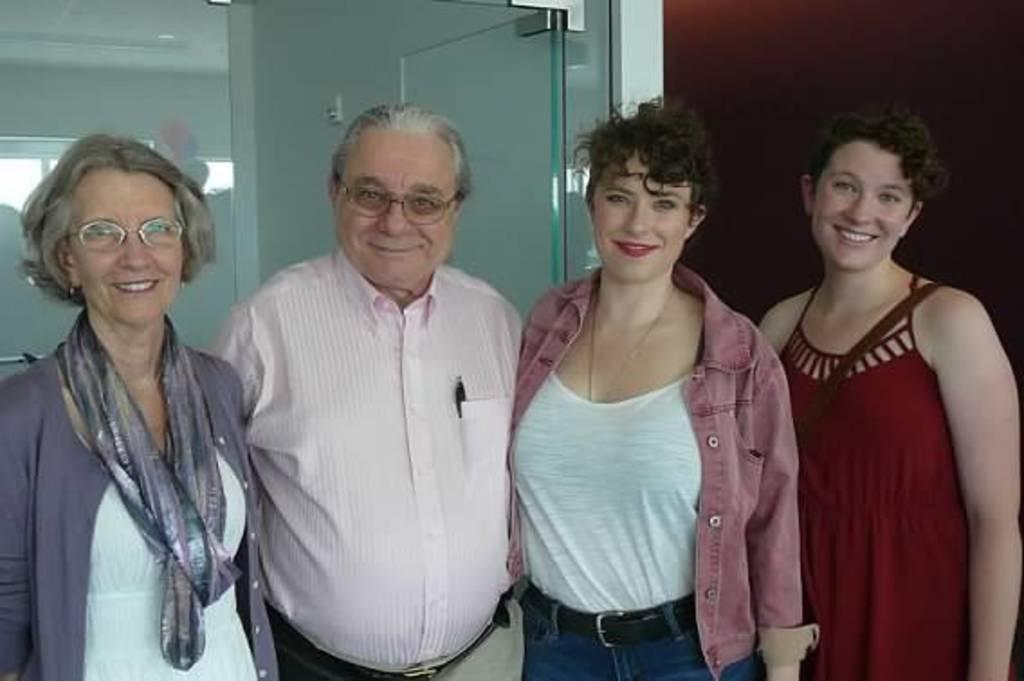Could you give a brief overview of what you see in this image? In the picture I can see a man and three women are standing and smiling. In the background I can see glass wall and some other objects. 